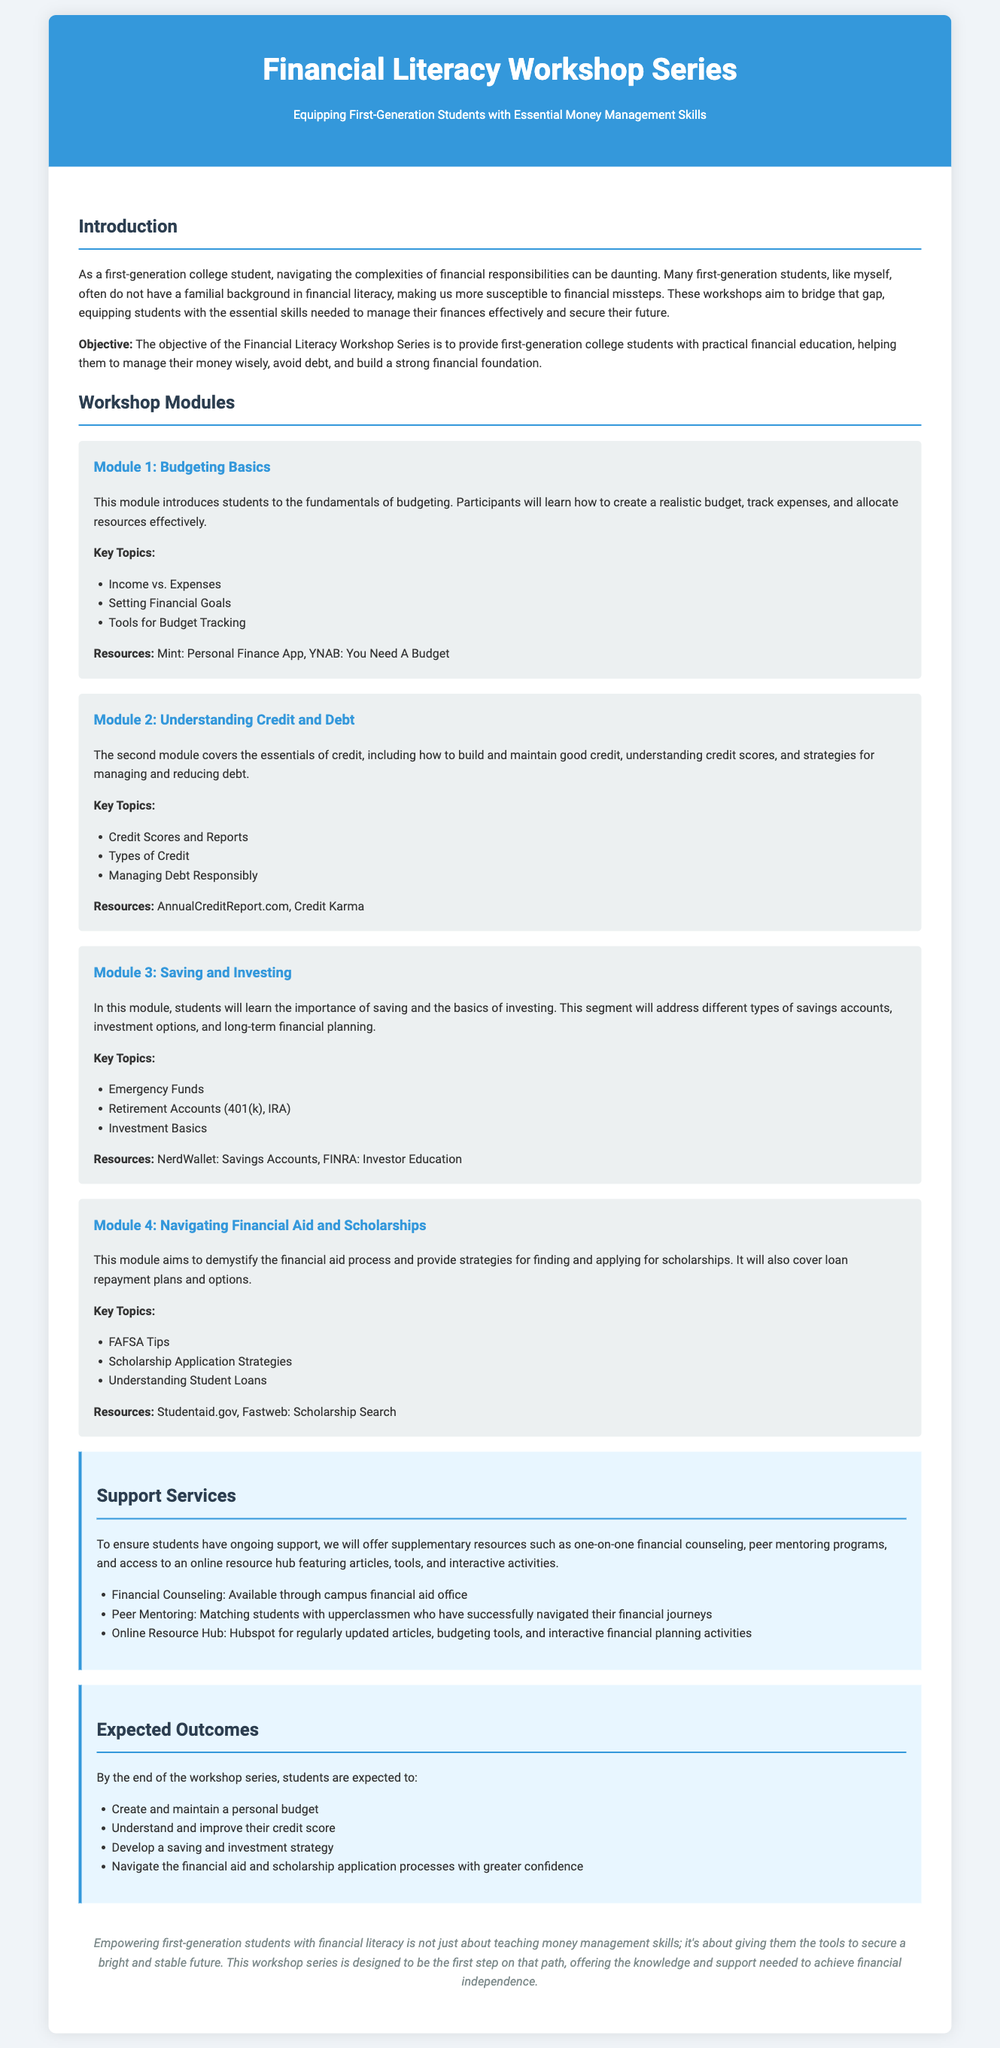What is the title of the workshop series? The title of the workshop series is presented in the header of the document.
Answer: Financial Literacy Workshop Series Who is the target audience for the workshops? The document specifies the target audience, which is highlighted in the introduction.
Answer: First-generation college students What is the objective of the workshop? The objective is stated clearly in the introduction section of the document.
Answer: To provide first-generation college students with practical financial education Name one resource provided in the Budgeting Basics module. The document lists specific resources under each module, including budgeting tools.
Answer: Mint: Personal Finance App What is one expected outcome of the workshop series? The document outlines several expected outcomes for participants at the end of the series.
Answer: Create and maintain a personal budget Which module covers understanding credit scores? The modules are numbered and titled, making it easy to identify the specific area of focus.
Answer: Module 2: Understanding Credit and Debt How many total modules are described in the document? The number of modules can be counted by looking at the sections under the Workshop Modules.
Answer: Four What support service is offered for financial counseling? The document mentions specific support services available for ongoing student support.
Answer: Available through campus financial aid office 